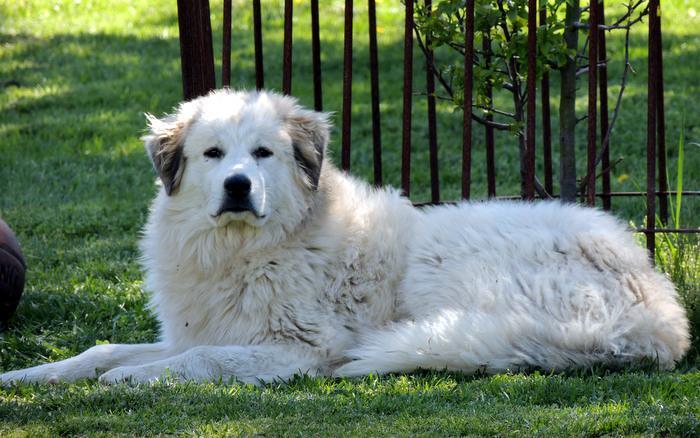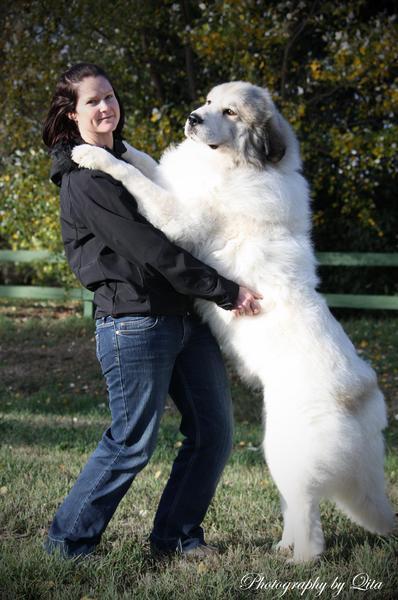The first image is the image on the left, the second image is the image on the right. Assess this claim about the two images: "There are at least two white dogs in the right image.". Correct or not? Answer yes or no. No. The first image is the image on the left, the second image is the image on the right. Assess this claim about the two images: "A large white dog at an outdoor setting is standing in a pose with a woman wearing jeans, who is leaning back slightly away from the dog.". Correct or not? Answer yes or no. Yes. 